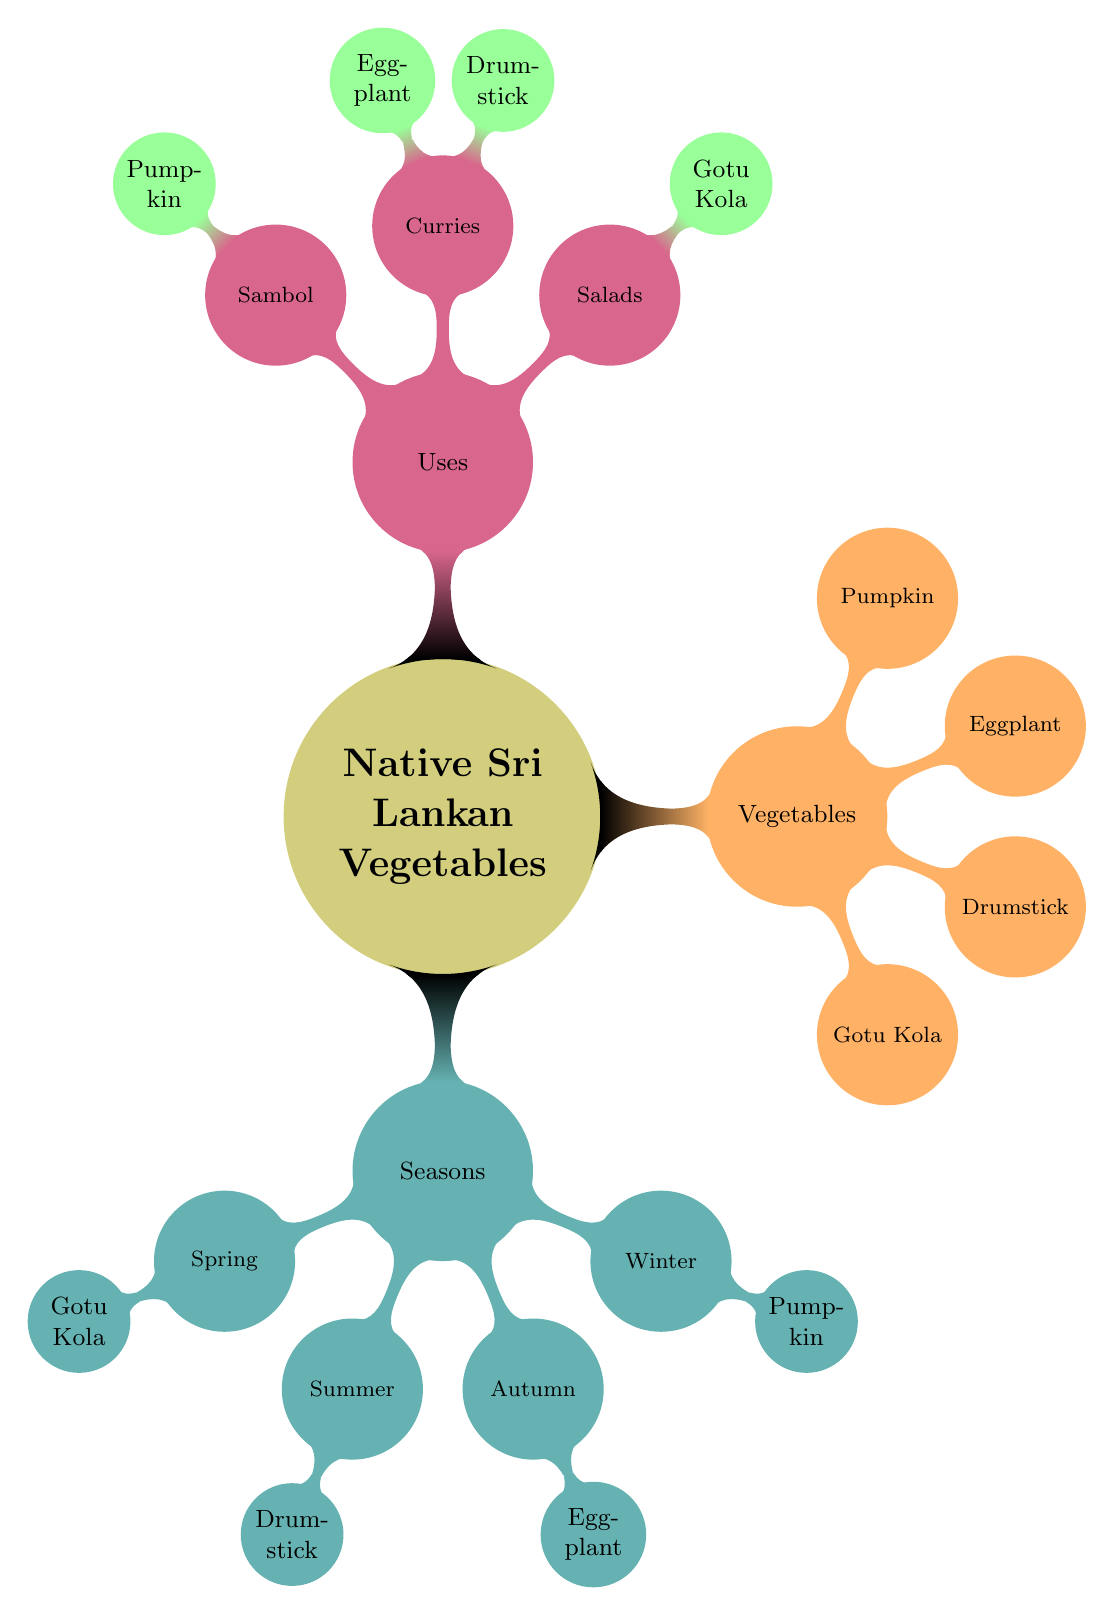What are the four seasons mentioned in the diagram? The diagram lists the four seasons as Spring, Summer, Autumn, and Winter. Each season corresponds to the availability of a specific native Sri Lankan vegetable.
Answer: Spring, Summer, Autumn, Winter Which vegetable is associated with Autumn? Looking at the Autumn node in the diagram, the vegetable listed under it is Eggplant.
Answer: Eggplant How many vegetables are listed in the diagram? Counting the vegetables from the Vegetables node, we find Gotu Kola, Drumstick, Eggplant, and Pumpkin, which totals four vegetables.
Answer: 4 What use is associated with Gotu Kola? In the Uses section of the diagram, Gotu Kola is specifically mentioned under the Salads category.
Answer: Salads Which season does Drumstick belong to? The diagram identifies Drumstick under the Summer node, indicating its availability in that season.
Answer: Summer Which two vegetables are used in curries? Under the Uses section, the two vegetables listed for curries are Drumstick and Eggplant. Both are linked under the Curries category.
Answer: Drumstick, Eggplant What is the primary use for Pumpkin according to the diagram? The diagram shows that Pumpkin is designated for use in Sambol, indicating its culinary application.
Answer: Sambol Which vegetable appears in both the Vegetables and Uses sections? The vegetable that appears in both sections is Eggplant, found listed under Vegetables as well as under Curries in the Uses section.
Answer: Eggplant Which vegetable is associated with the Spring season? Looking at the Spring node, the vegetable listed is Gotu Kola, indicating its seasonal availability.
Answer: Gotu Kola 